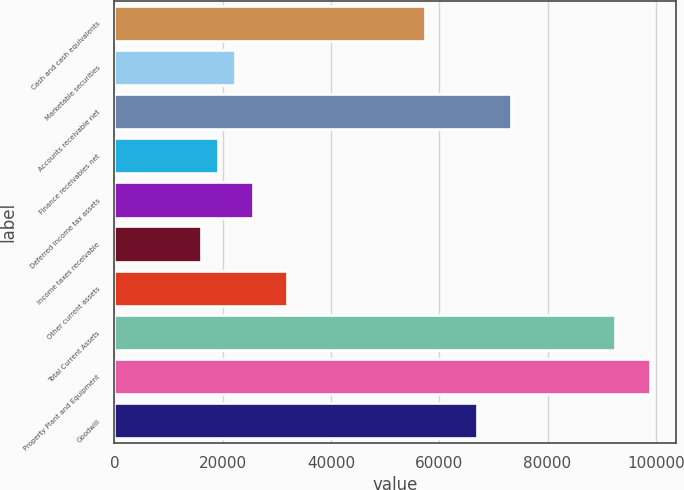Convert chart. <chart><loc_0><loc_0><loc_500><loc_500><bar_chart><fcel>Cash and cash equivalents<fcel>Marketable securities<fcel>Accounts receivable net<fcel>Finance receivables net<fcel>Deferred income tax assets<fcel>Income taxes receivable<fcel>Other current assets<fcel>Total Current Assets<fcel>Property Plant and Equipment<fcel>Goodwill<nl><fcel>57387<fcel>22319<fcel>73327<fcel>19131<fcel>25507<fcel>15943<fcel>31883<fcel>92455<fcel>98831<fcel>66951<nl></chart> 